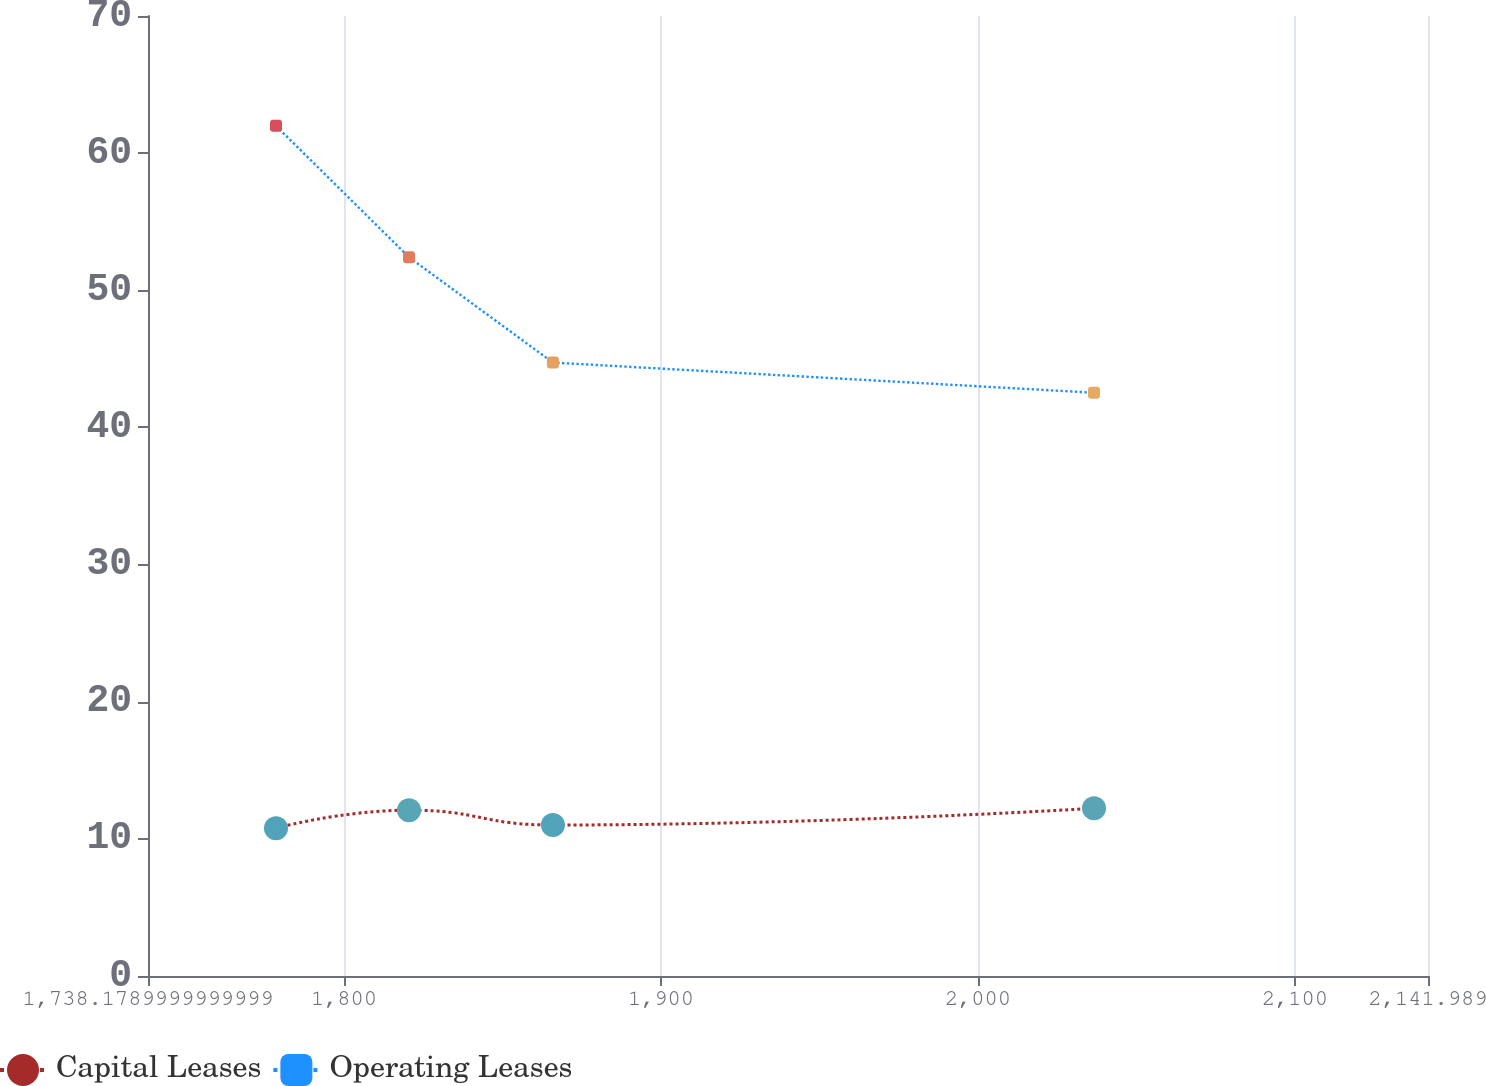<chart> <loc_0><loc_0><loc_500><loc_500><line_chart><ecel><fcel>Capital Leases<fcel>Operating Leases<nl><fcel>1778.56<fcel>10.78<fcel>61.99<nl><fcel>1820.52<fcel>12.09<fcel>52.41<nl><fcel>1865.92<fcel>11.01<fcel>44.73<nl><fcel>2036.62<fcel>12.23<fcel>42.53<nl><fcel>2182.37<fcel>12.37<fcel>47.44<nl></chart> 